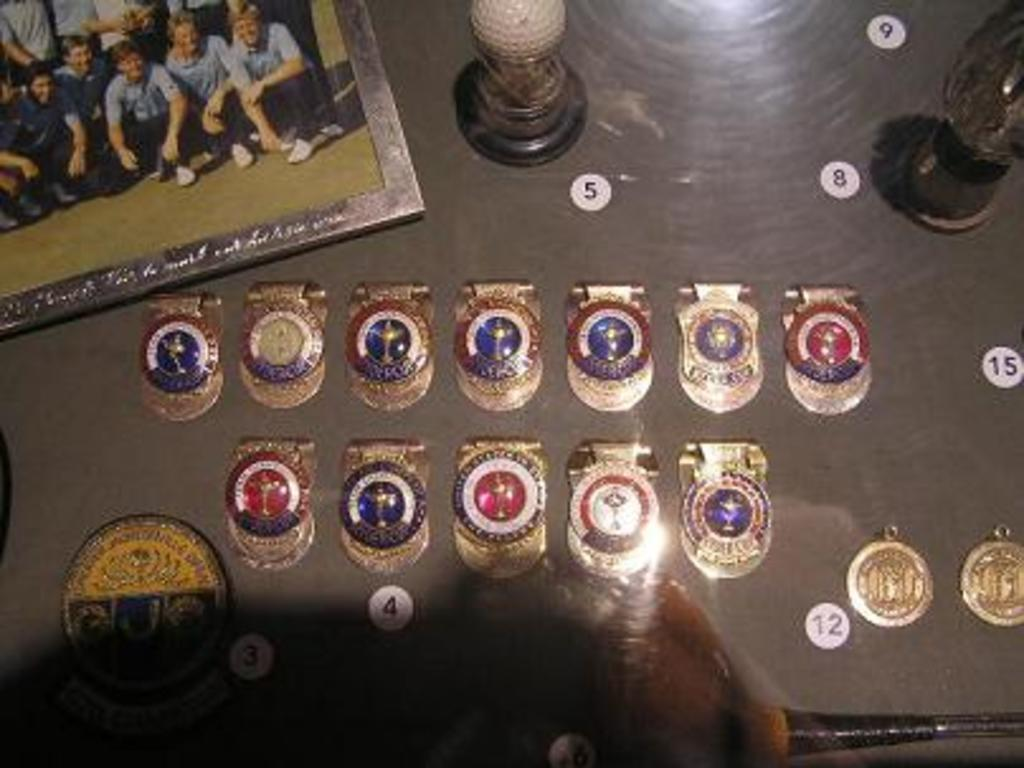<image>
Share a concise interpretation of the image provided. A table with numbers visible on it - five and eight are two of these. 